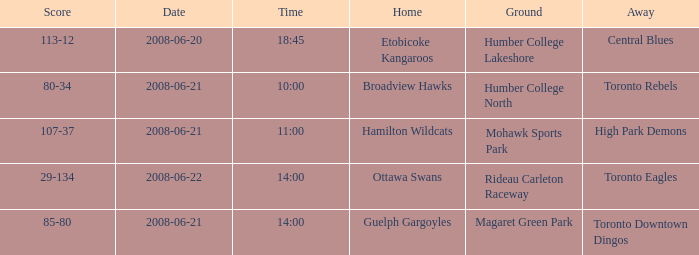What is the Time with a Score that is 80-34? 10:00. 